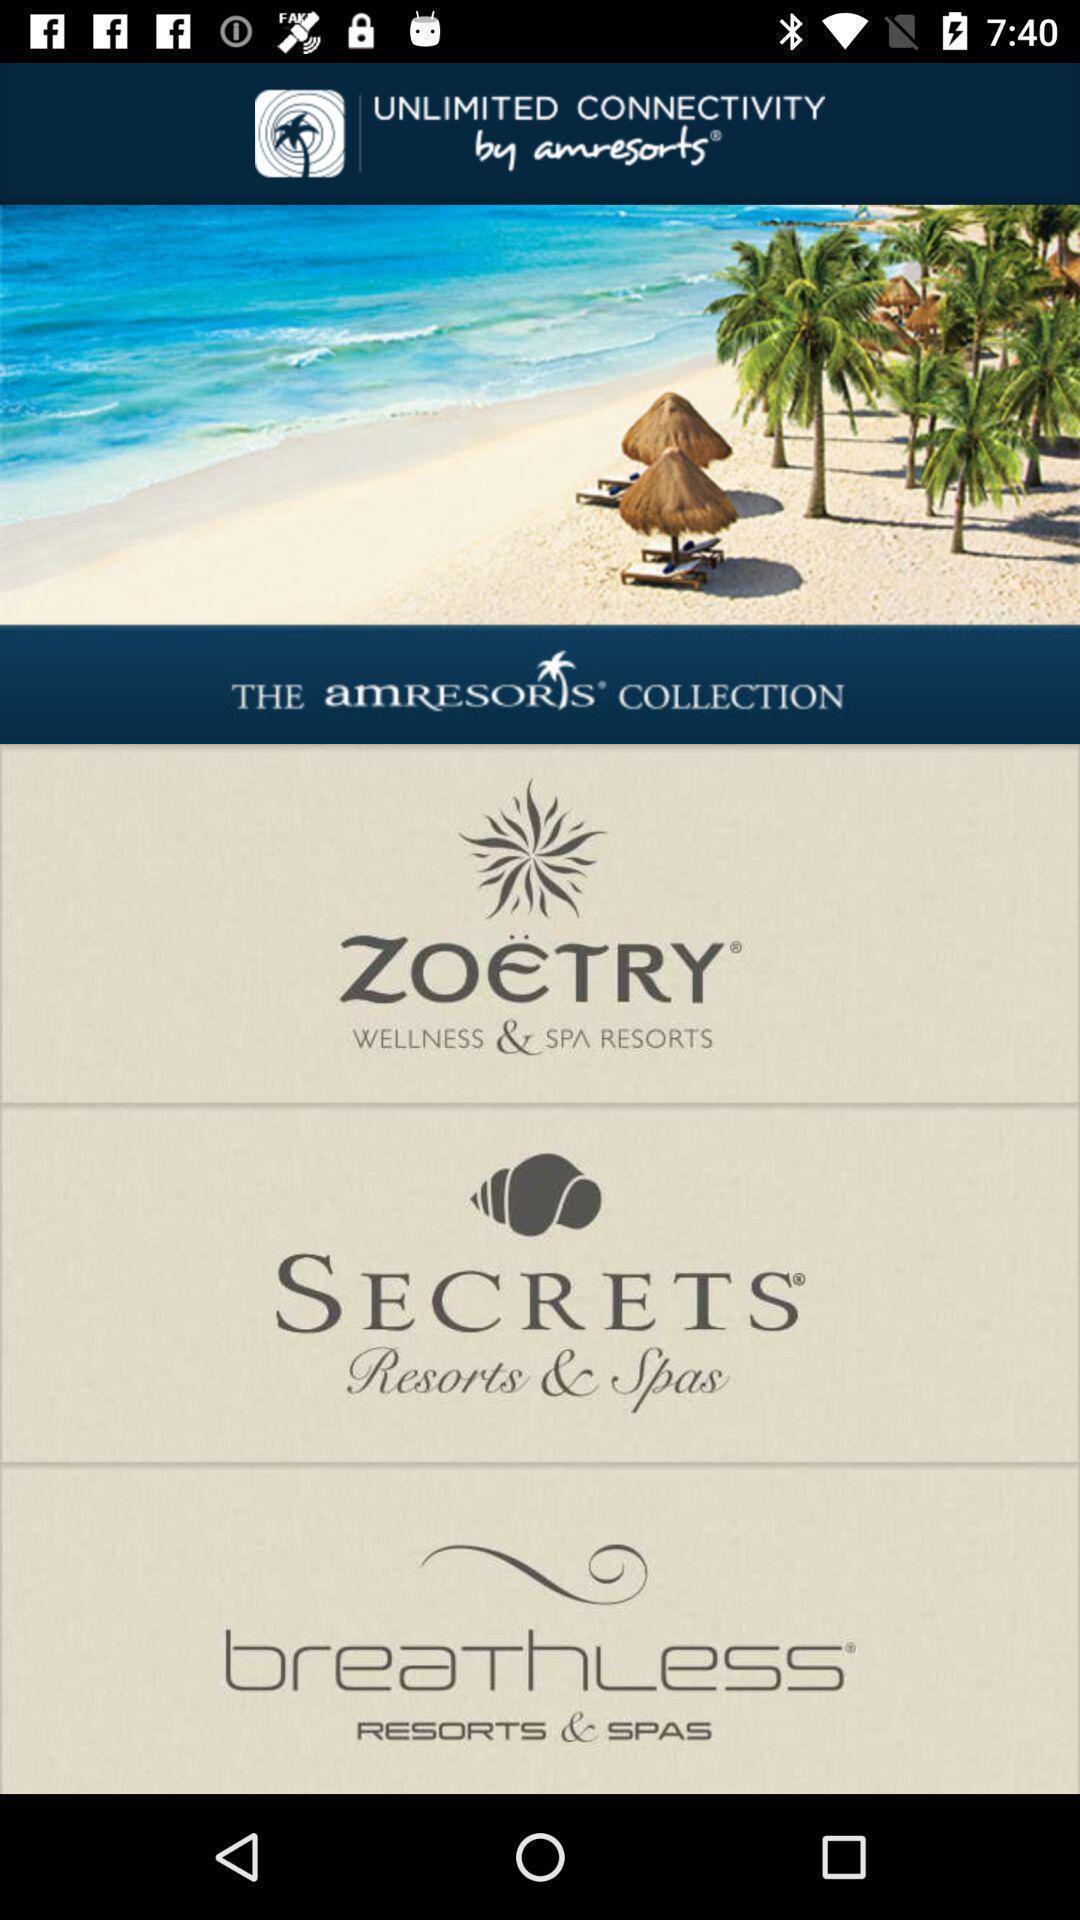Describe this image in words. Welcome page for a hotels app. 